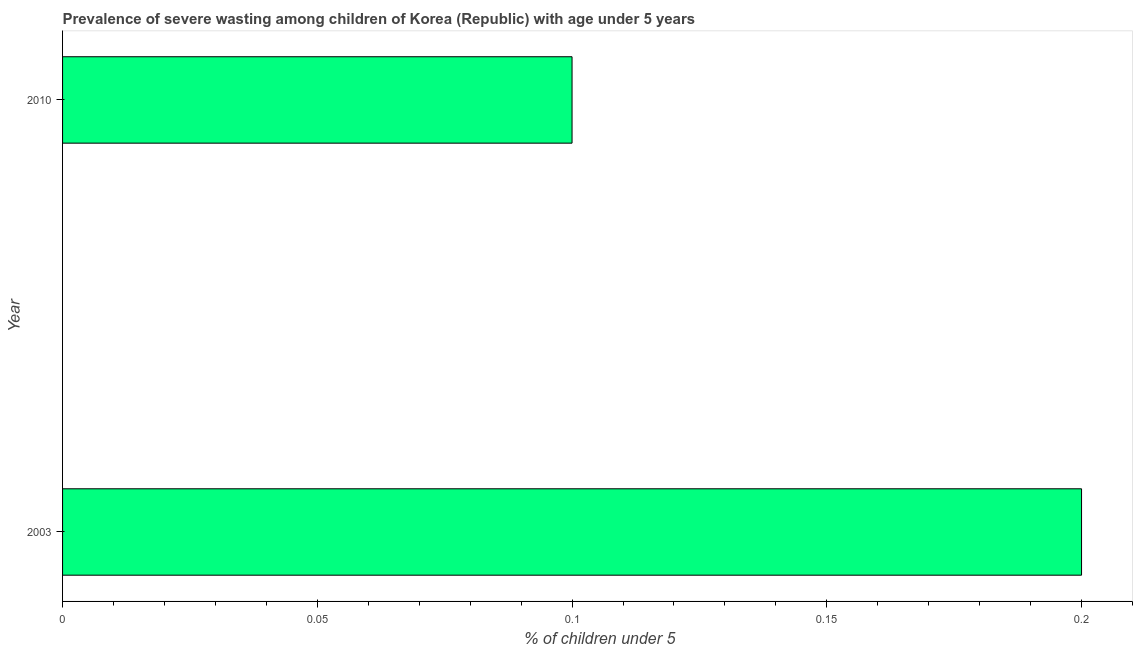Does the graph contain any zero values?
Keep it short and to the point. No. Does the graph contain grids?
Keep it short and to the point. No. What is the title of the graph?
Your response must be concise. Prevalence of severe wasting among children of Korea (Republic) with age under 5 years. What is the label or title of the X-axis?
Offer a terse response.  % of children under 5. What is the label or title of the Y-axis?
Offer a terse response. Year. What is the prevalence of severe wasting in 2010?
Your answer should be compact. 0.1. Across all years, what is the maximum prevalence of severe wasting?
Keep it short and to the point. 0.2. Across all years, what is the minimum prevalence of severe wasting?
Ensure brevity in your answer.  0.1. In which year was the prevalence of severe wasting maximum?
Offer a very short reply. 2003. What is the sum of the prevalence of severe wasting?
Offer a terse response. 0.3. What is the median prevalence of severe wasting?
Offer a terse response. 0.15. Do a majority of the years between 2003 and 2010 (inclusive) have prevalence of severe wasting greater than 0.09 %?
Offer a terse response. Yes. What is the ratio of the prevalence of severe wasting in 2003 to that in 2010?
Make the answer very short. 2. In how many years, is the prevalence of severe wasting greater than the average prevalence of severe wasting taken over all years?
Keep it short and to the point. 1. How many bars are there?
Ensure brevity in your answer.  2. Are all the bars in the graph horizontal?
Give a very brief answer. Yes. What is the difference between two consecutive major ticks on the X-axis?
Offer a terse response. 0.05. What is the  % of children under 5 in 2003?
Offer a very short reply. 0.2. What is the  % of children under 5 in 2010?
Offer a very short reply. 0.1. 